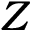Convert formula to latex. <formula><loc_0><loc_0><loc_500><loc_500>Z</formula> 